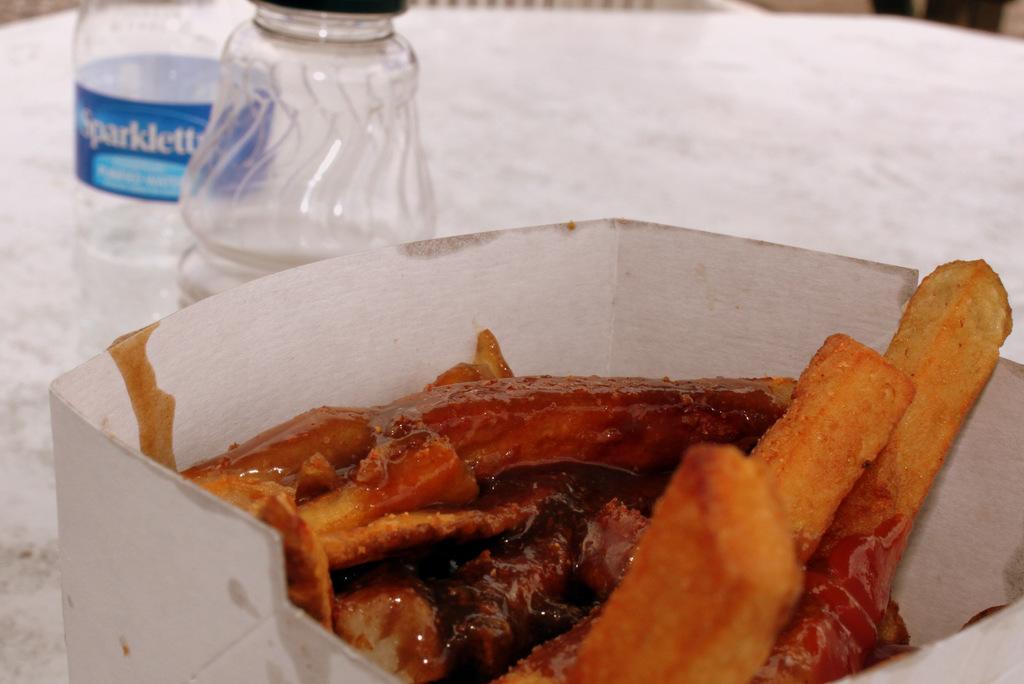What is the name of the water bottle?
Your response must be concise. Sparklett. 